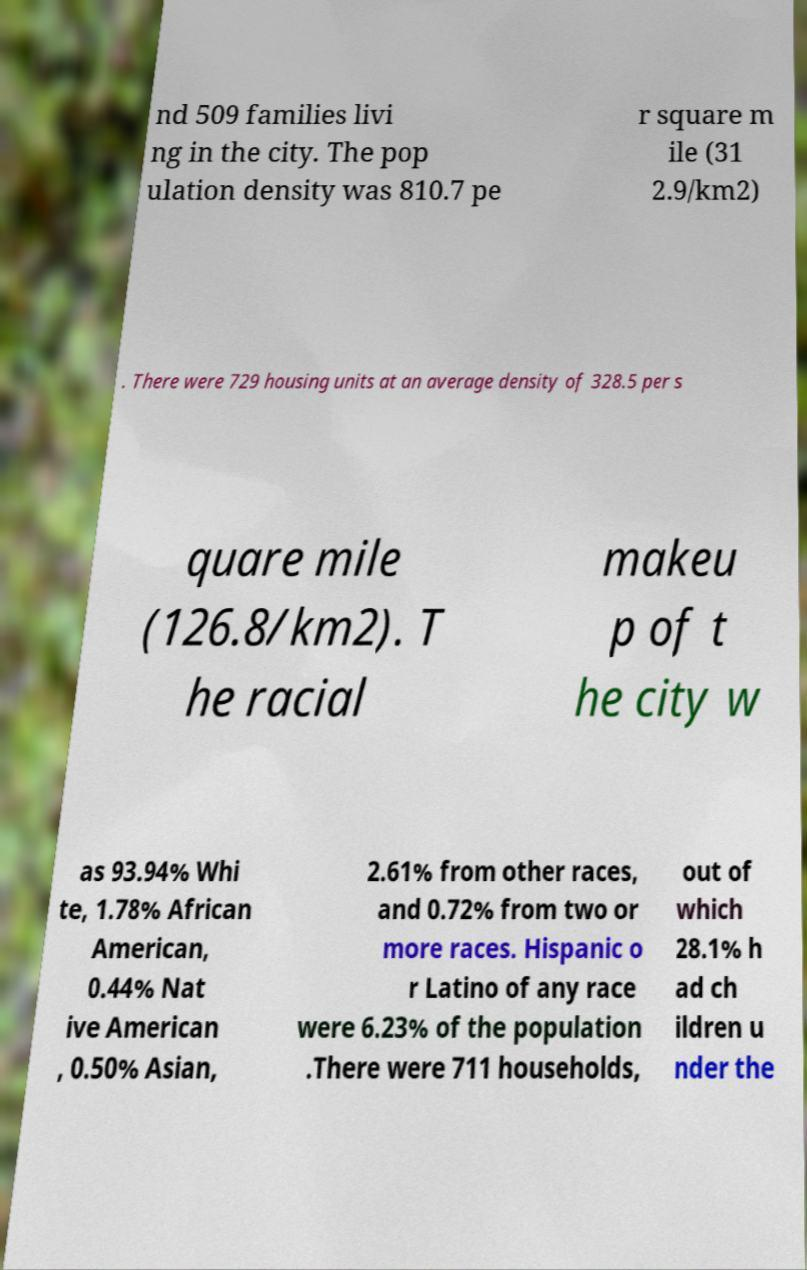Please read and relay the text visible in this image. What does it say? nd 509 families livi ng in the city. The pop ulation density was 810.7 pe r square m ile (31 2.9/km2) . There were 729 housing units at an average density of 328.5 per s quare mile (126.8/km2). T he racial makeu p of t he city w as 93.94% Whi te, 1.78% African American, 0.44% Nat ive American , 0.50% Asian, 2.61% from other races, and 0.72% from two or more races. Hispanic o r Latino of any race were 6.23% of the population .There were 711 households, out of which 28.1% h ad ch ildren u nder the 